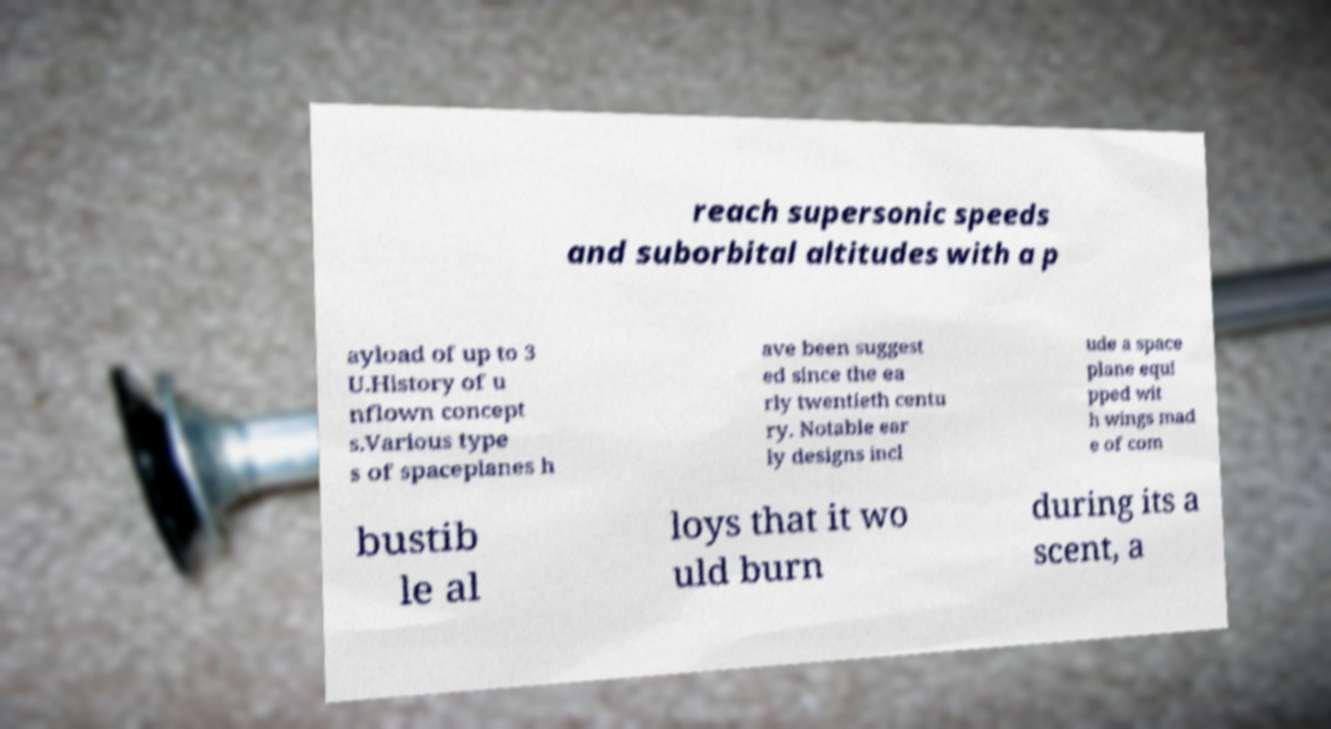For documentation purposes, I need the text within this image transcribed. Could you provide that? reach supersonic speeds and suborbital altitudes with a p ayload of up to 3 U.History of u nflown concept s.Various type s of spaceplanes h ave been suggest ed since the ea rly twentieth centu ry. Notable ear ly designs incl ude a space plane equi pped wit h wings mad e of com bustib le al loys that it wo uld burn during its a scent, a 